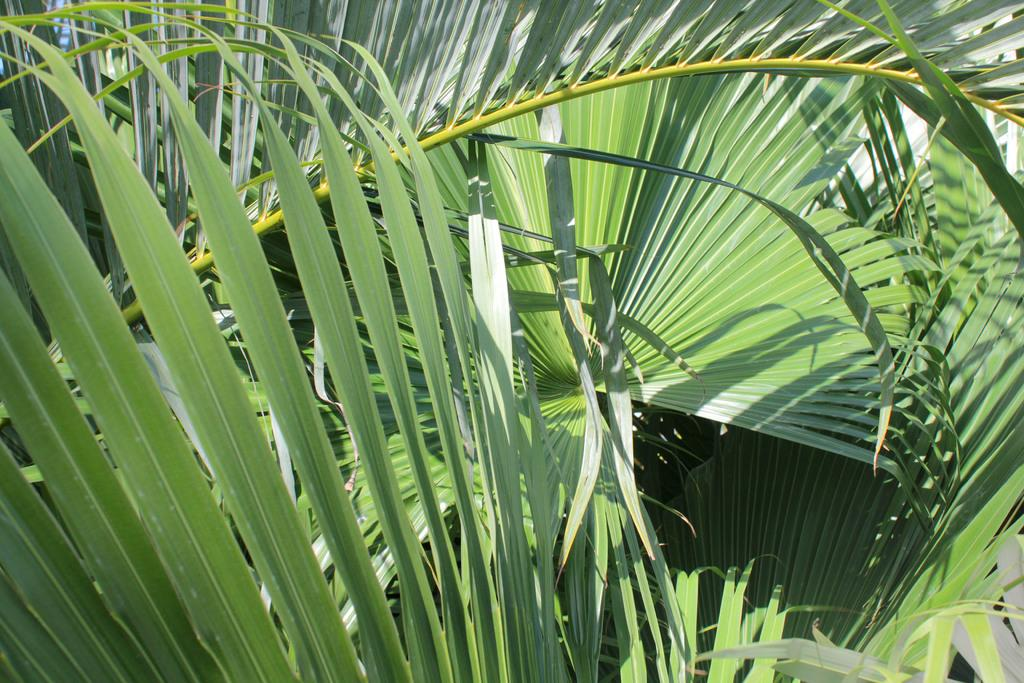What type of tree branches are visible in the image? There are coconut tree branches in the image. What can be found on the branches of the coconut trees? The branches have leaves. How does the board bend in the image? There is no board present in the image; it only features coconut tree branches with leaves. 